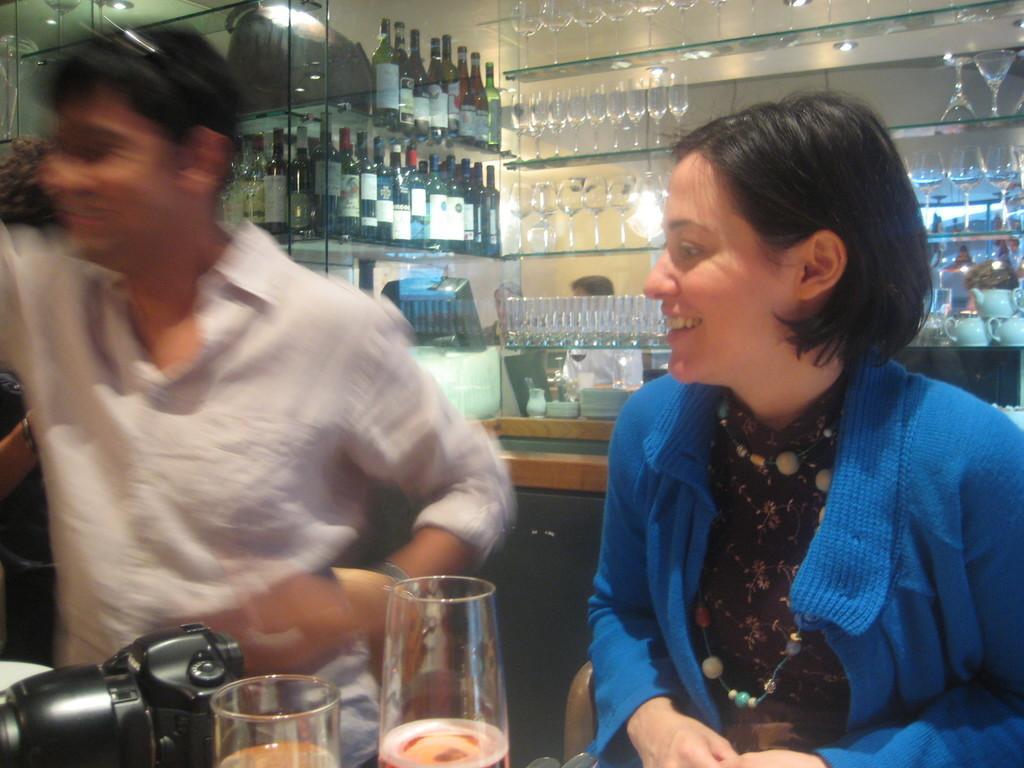Could you give a brief overview of what you see in this image? In this image in the front there are glasses and there is a camera. In the center there a persons smiling and in the background there are bottles, glasses, cups and there is a reflection of the persons on the mirror which is in the background. 